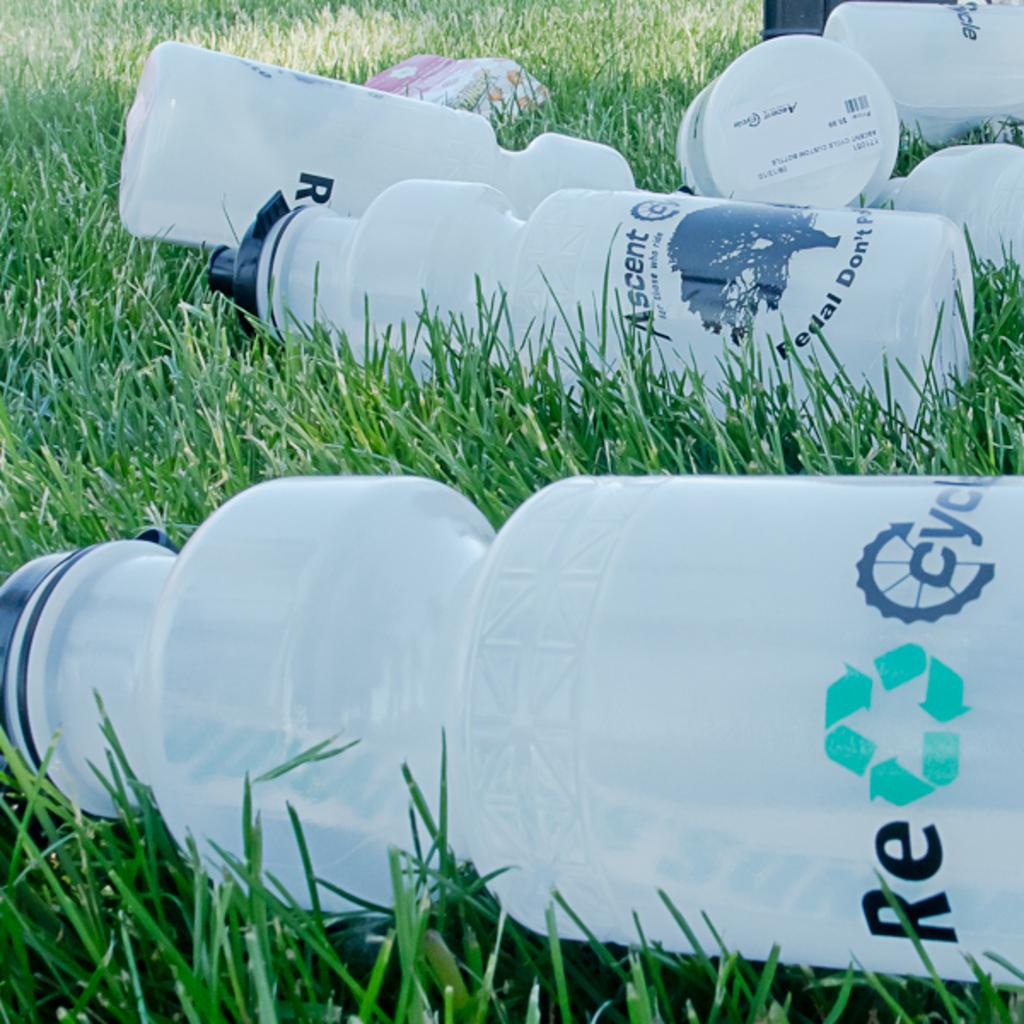What objects are present in the image? There are bottles and a box in the image. Where are the bottles and box located? The bottles and box are on the grass. Can you describe the surface on which the objects are placed? The objects are placed on the grass. What type of shoes can be seen in the image? There are no shoes present in the image; it features bottles and a box on the grass. What material is the notebook made of in the image? There is no notebook present in the image. 